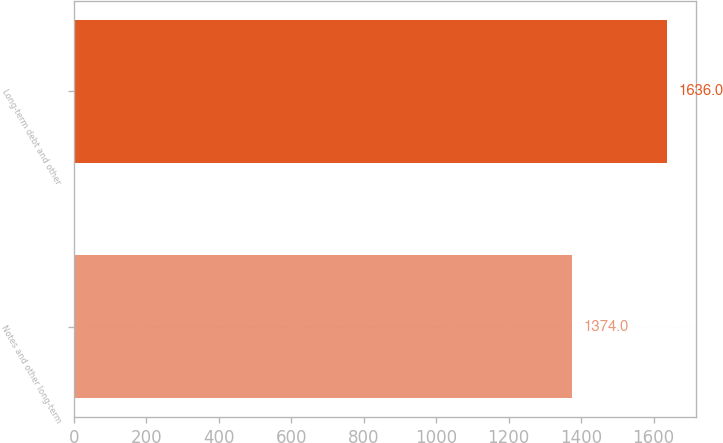<chart> <loc_0><loc_0><loc_500><loc_500><bar_chart><fcel>Notes and other long-term<fcel>Long-term debt and other<nl><fcel>1374<fcel>1636<nl></chart> 